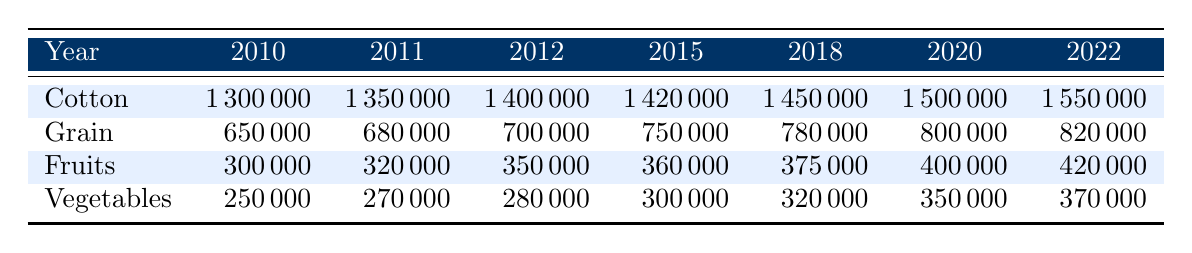What was the production of cotton in 2012? Looking at the row for cotton in the column for the year 2012, the production value is 1400000.
Answer: 1400000 Which crop type has the highest production in 2020? In the year 2020, I can see from the table that cotton has the highest production at 1500000, compared to the other crops.
Answer: Cotton What is the total production of fruits from 2010 to 2022? To find the total production of fruits, I need to sum the values for each year: 300000 + 320000 + 350000 + 360000 + 375000 + 400000 + 420000 = 2100000.
Answer: 2100000 Did the production of grain increase every year from 2010 to 2022? By observing the values for grain from each year, I see the following numbers: 650000, 680000, 700000, 750000, 780000, 800000, and 820000, which all show an increase each year. Thus, the statement is true.
Answer: Yes What was the average production of vegetables from 2015 to 2022? The total production of vegetables for the years 2015 to 2022 is 300000 + 320000 + 350000 + 370000 = 1340000. Since there are 7 years in total, the average is 1340000 / 7 = 191428.57.
Answer: 191428.57 How much did fruit production increase from 2010 to 2022? I need to find the production values for fruits in those years: in 2010 it was 300000 and in 2022 it was 420000. The increase is calculated as 420000 - 300000 = 120000.
Answer: 120000 Which crop had the least production in 2018? Referring to the production values for the year 2018: cotton (1450000), grain (780000), fruits (375000), and vegetables (320000), vegetables had the least production at 320000.
Answer: Vegetables What is the difference in cotton production between 2010 and 2022? I look at the values for cotton: in 2010 it was 1300000 and in 2022 it was 1550000. The difference is 1550000 - 1300000 = 250000.
Answer: 250000 